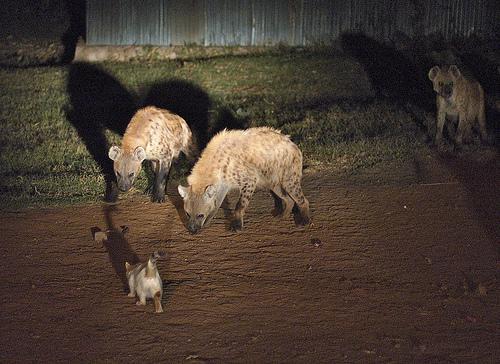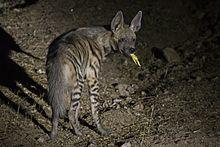The first image is the image on the left, the second image is the image on the right. Assess this claim about the two images: "there are at least three hyenas in the image on the left". Correct or not? Answer yes or no. Yes. The first image is the image on the left, the second image is the image on the right. Examine the images to the left and right. Is the description "There is one baby hyena." accurate? Answer yes or no. Yes. 